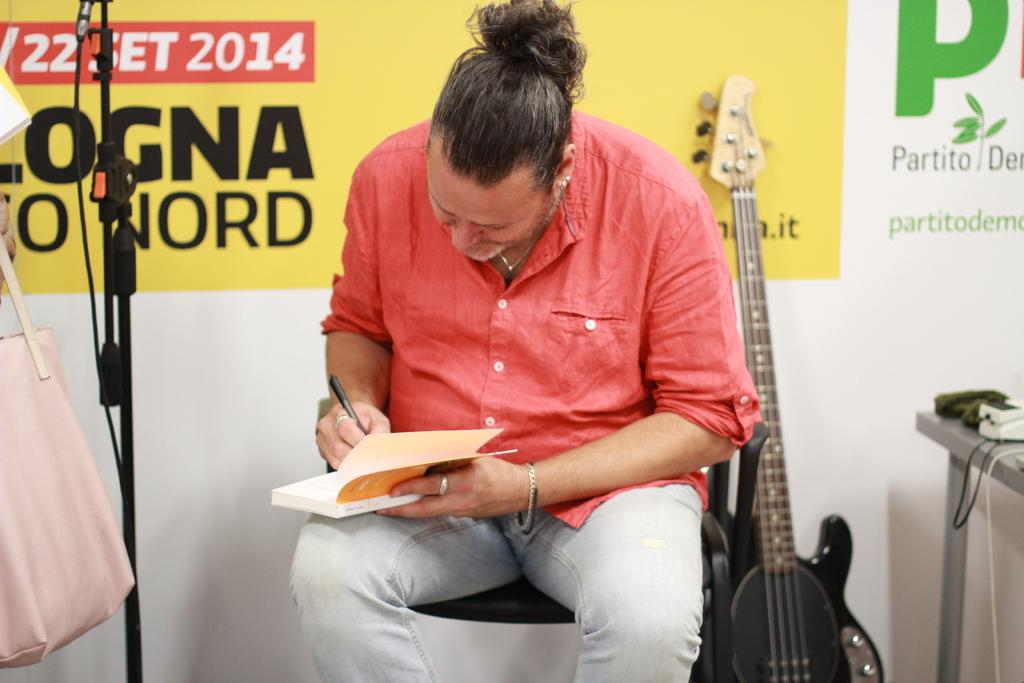<image>
Offer a succinct explanation of the picture presented. A man signing a book with a sign saying2014 behind him. 